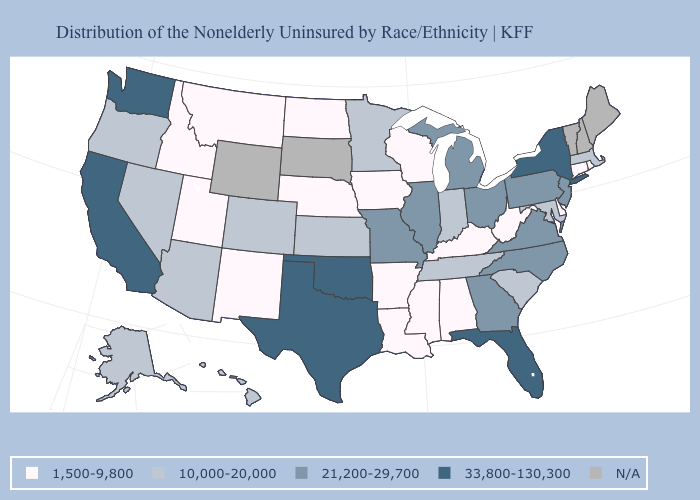What is the value of South Carolina?
Be succinct. 10,000-20,000. What is the lowest value in the USA?
Write a very short answer. 1,500-9,800. Name the states that have a value in the range 1,500-9,800?
Give a very brief answer. Alabama, Arkansas, Connecticut, Delaware, Idaho, Iowa, Kentucky, Louisiana, Mississippi, Montana, Nebraska, New Mexico, North Dakota, Rhode Island, Utah, West Virginia, Wisconsin. What is the value of Montana?
Answer briefly. 1,500-9,800. Does North Dakota have the lowest value in the MidWest?
Give a very brief answer. Yes. What is the value of New York?
Keep it brief. 33,800-130,300. Does the first symbol in the legend represent the smallest category?
Be succinct. Yes. Does Alabama have the highest value in the USA?
Quick response, please. No. Does West Virginia have the highest value in the USA?
Concise answer only. No. Among the states that border Colorado , does Oklahoma have the highest value?
Keep it brief. Yes. What is the highest value in the MidWest ?
Give a very brief answer. 21,200-29,700. What is the highest value in the USA?
Give a very brief answer. 33,800-130,300. Name the states that have a value in the range N/A?
Quick response, please. Maine, New Hampshire, South Dakota, Vermont, Wyoming. Which states have the lowest value in the West?
Short answer required. Idaho, Montana, New Mexico, Utah. 